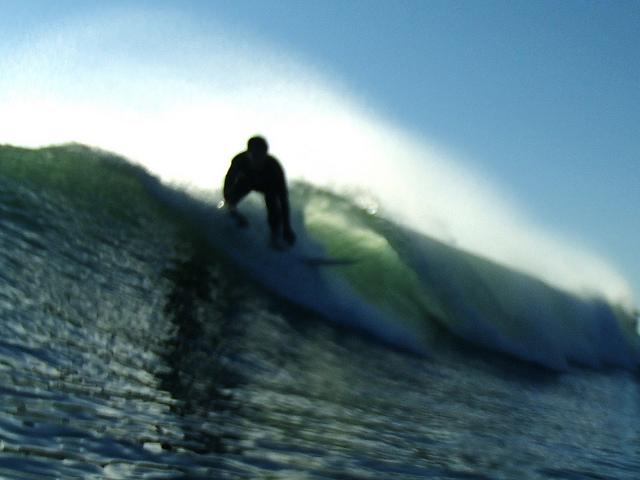Is the person surfing?
Quick response, please. Yes. What is the person doing?
Give a very brief answer. Surfing. Why is the person dark in this picture?
Write a very short answer. Shadow. 